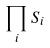Convert formula to latex. <formula><loc_0><loc_0><loc_500><loc_500>\prod _ { i } S _ { i }</formula> 